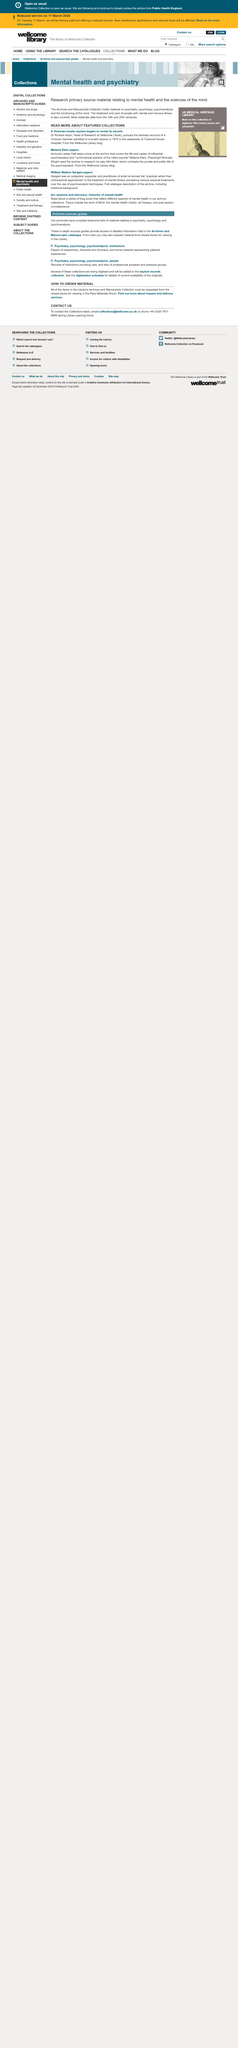Highlight a few significant elements in this photo. Dr. Richard Aspin is the head of research at the Wellcome Library. The life and career of Melanie Klein, a controversial explorer, is the subject of the archive. In the year 1875, a Victorian barrister was admitted to a lunatic asylum. 